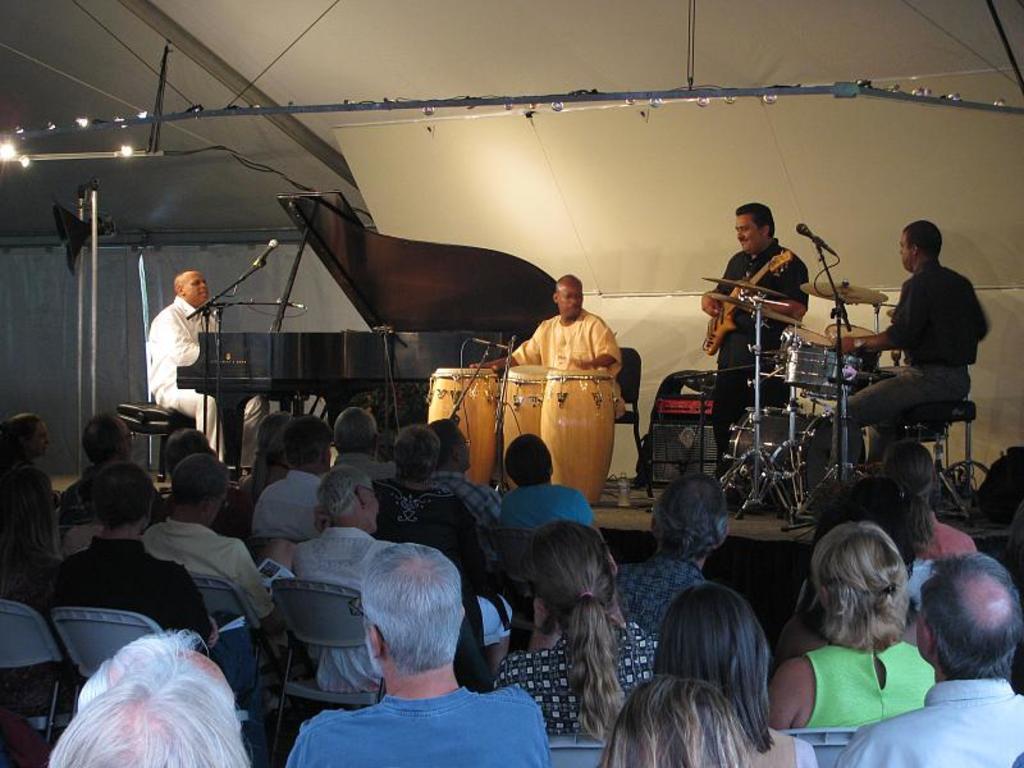Can you describe this image briefly? There is a group of people. They are playing musical instruments. Everyone is only looking at their side. 